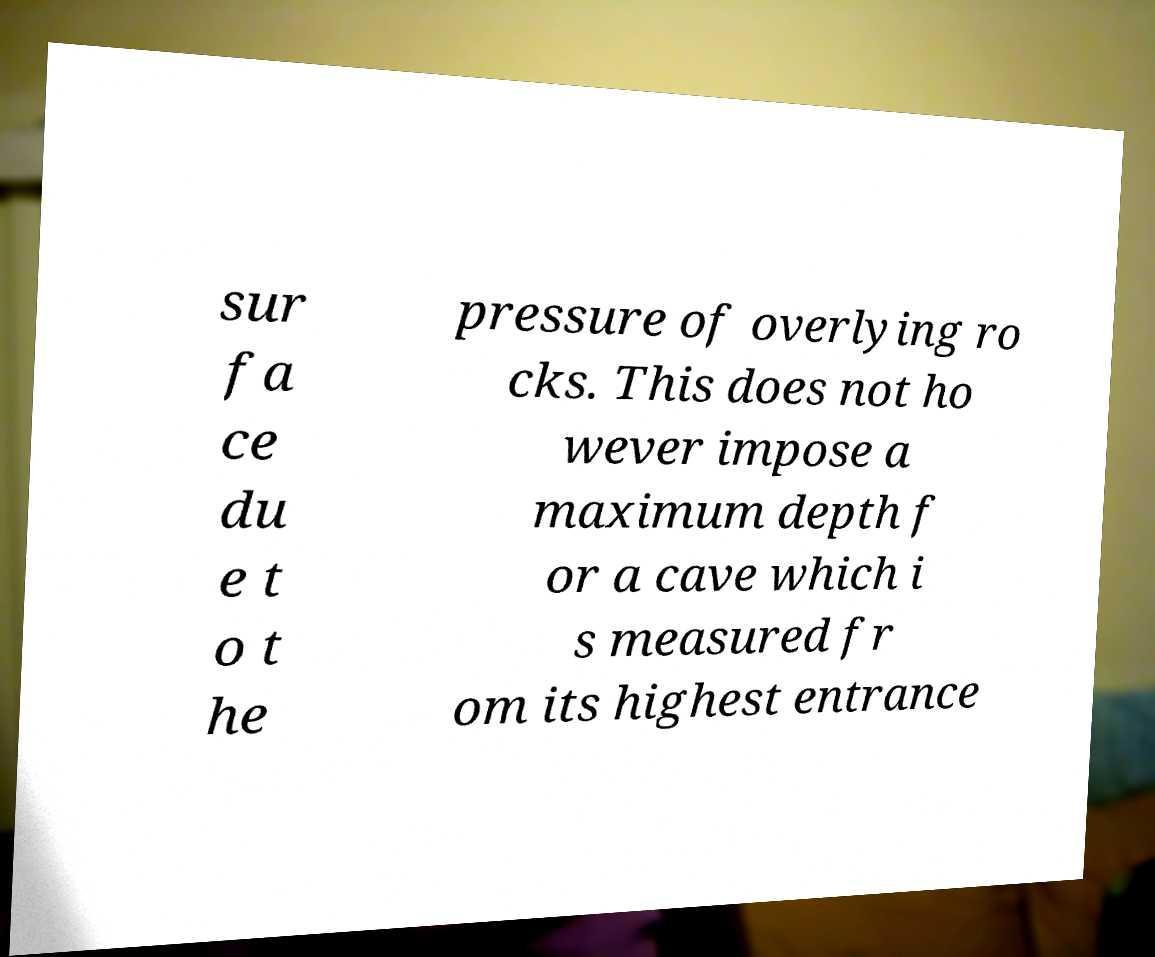Could you extract and type out the text from this image? sur fa ce du e t o t he pressure of overlying ro cks. This does not ho wever impose a maximum depth f or a cave which i s measured fr om its highest entrance 